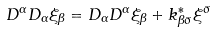<formula> <loc_0><loc_0><loc_500><loc_500>D ^ { \alpha } D _ { \alpha } \xi _ { \beta } = D _ { \alpha } D ^ { \alpha } \xi _ { \beta } + k ^ { * } _ { \beta \bar { \sigma } } \xi ^ { \bar { \sigma } }</formula> 